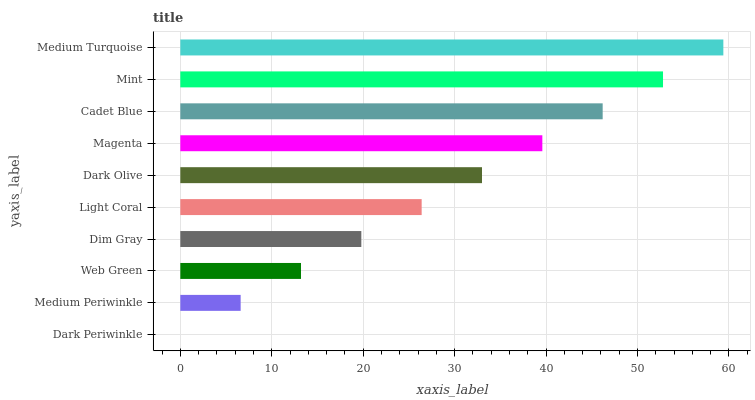Is Dark Periwinkle the minimum?
Answer yes or no. Yes. Is Medium Turquoise the maximum?
Answer yes or no. Yes. Is Medium Periwinkle the minimum?
Answer yes or no. No. Is Medium Periwinkle the maximum?
Answer yes or no. No. Is Medium Periwinkle greater than Dark Periwinkle?
Answer yes or no. Yes. Is Dark Periwinkle less than Medium Periwinkle?
Answer yes or no. Yes. Is Dark Periwinkle greater than Medium Periwinkle?
Answer yes or no. No. Is Medium Periwinkle less than Dark Periwinkle?
Answer yes or no. No. Is Dark Olive the high median?
Answer yes or no. Yes. Is Light Coral the low median?
Answer yes or no. Yes. Is Medium Periwinkle the high median?
Answer yes or no. No. Is Mint the low median?
Answer yes or no. No. 